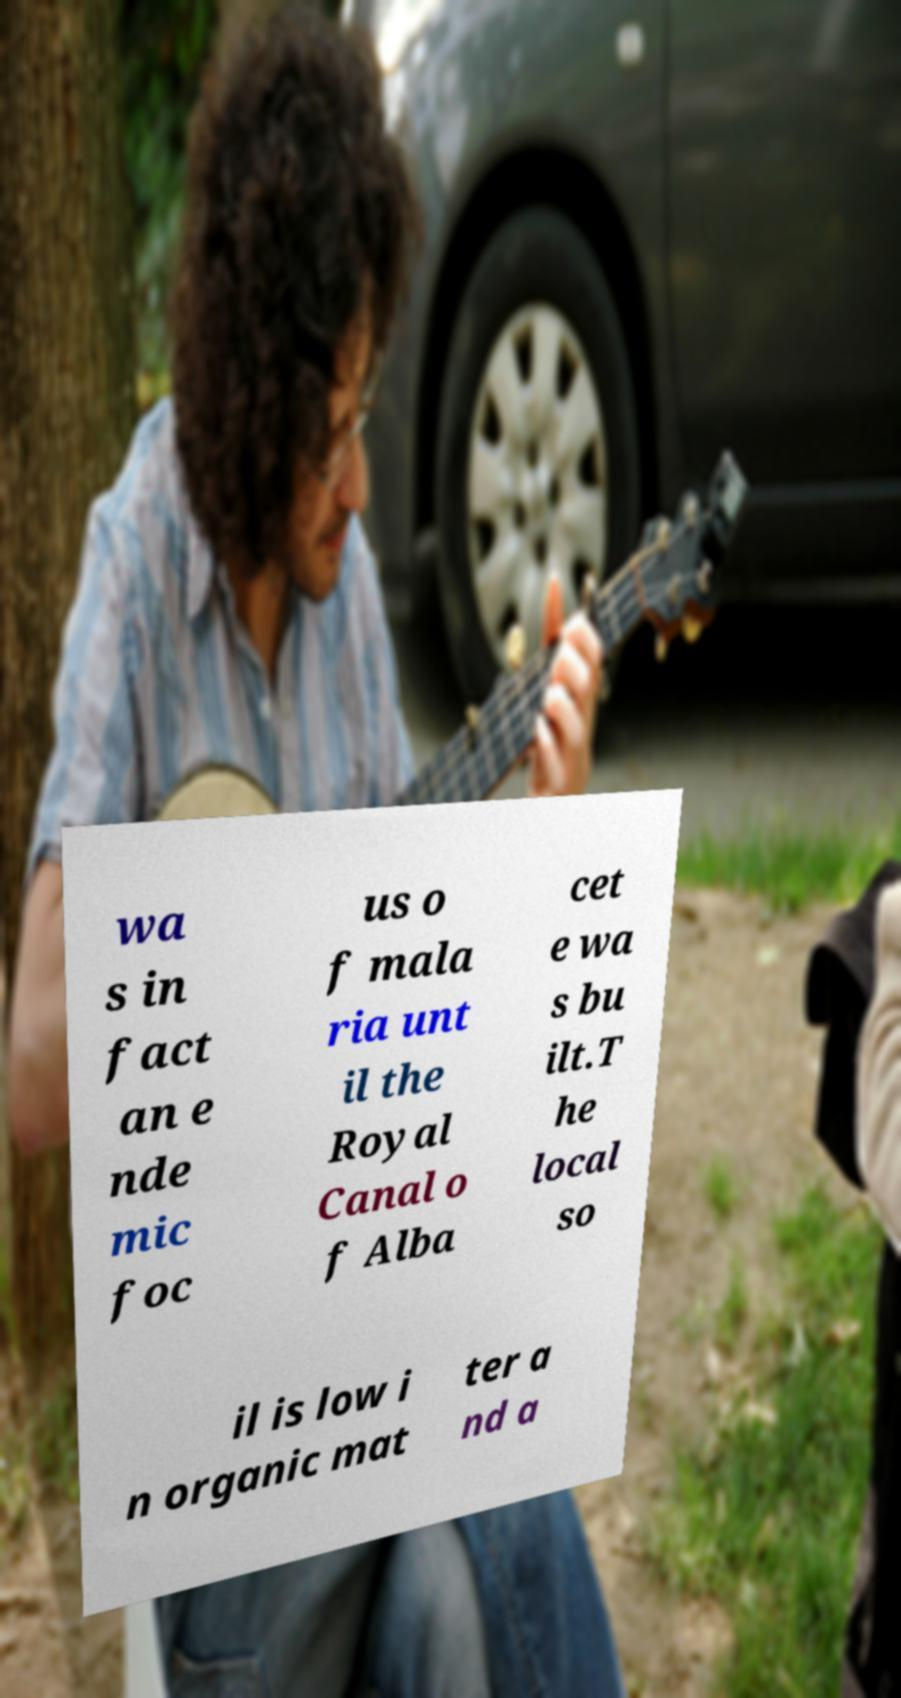Please identify and transcribe the text found in this image. wa s in fact an e nde mic foc us o f mala ria unt il the Royal Canal o f Alba cet e wa s bu ilt.T he local so il is low i n organic mat ter a nd a 